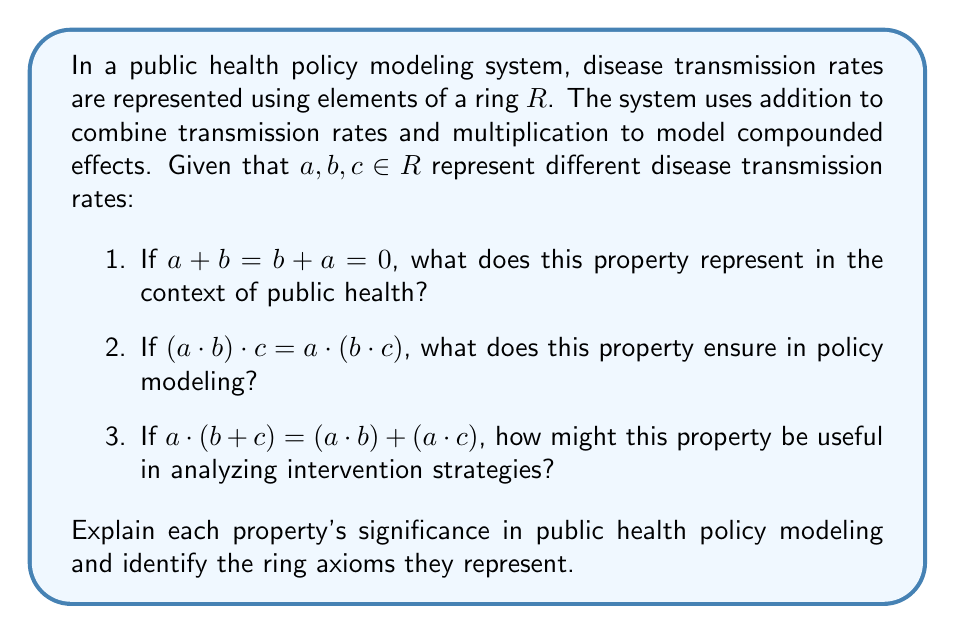Can you solve this math problem? This question applies ring theory to public health policy modeling, which is relevant to a data-driven public health official. Let's break down each part:

1) The property $a + b = b + a = 0$ represents the additive inverse in ring theory. In public health context, this could represent:
   - Two transmission rates that cancel each other out
   - A disease and its perfect countermeasure
   - Opposing effects in a population that result in no net change

This is the inverse element axiom for addition in ring theory.

2) The property $(a \cdot b) \cdot c = a \cdot (b \cdot c)$ represents associativity of multiplication in ring theory. In policy modeling, this ensures:
   - Consistency in calculations regardless of the order of applying multiple factors
   - Reliability in modeling complex interactions between multiple disease factors
   - Ability to group and analyze compound effects in different ways

This is the associative axiom for multiplication in ring theory.

3) The property $a \cdot (b + c) = (a \cdot b) + (a \cdot c)$ represents distributivity in ring theory. In analyzing intervention strategies, this could be useful for:
   - Modeling how one factor affects the sum of two other factors
   - Analyzing the combined effect of an intervention on multiple transmission routes
   - Breaking down complex interventions into simpler components for analysis

This is the distributive axiom in ring theory.

These properties ensure that the mathematical model behaves consistently and predictably, allowing for reliable analysis and forecasting in public health policy. They provide a rigorous framework for combining and analyzing different factors affecting disease transmission and intervention effectiveness.
Answer: 1) Additive inverse axiom: Represents factors that cancel out or counterbalance in public health.
2) Associative axiom for multiplication: Ensures consistency in modeling compound effects of multiple factors.
3) Distributive axiom: Allows for breaking down and analyzing complex interventions in terms of simpler components. 